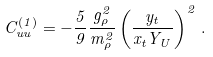Convert formula to latex. <formula><loc_0><loc_0><loc_500><loc_500>C _ { u u } ^ { ( 1 ) } = - \frac { 5 } { 9 } \frac { g _ { \rho } ^ { 2 } } { m _ { \rho } ^ { 2 } } \left ( \frac { y _ { t } } { x _ { t } Y _ { U } } \right ) ^ { 2 } \, .</formula> 